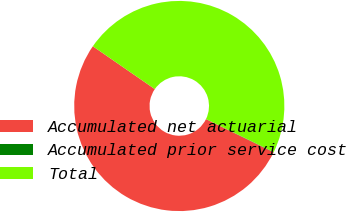Convert chart. <chart><loc_0><loc_0><loc_500><loc_500><pie_chart><fcel>Accumulated net actuarial<fcel>Accumulated prior service cost<fcel>Total<nl><fcel>52.36%<fcel>0.05%<fcel>47.6%<nl></chart> 